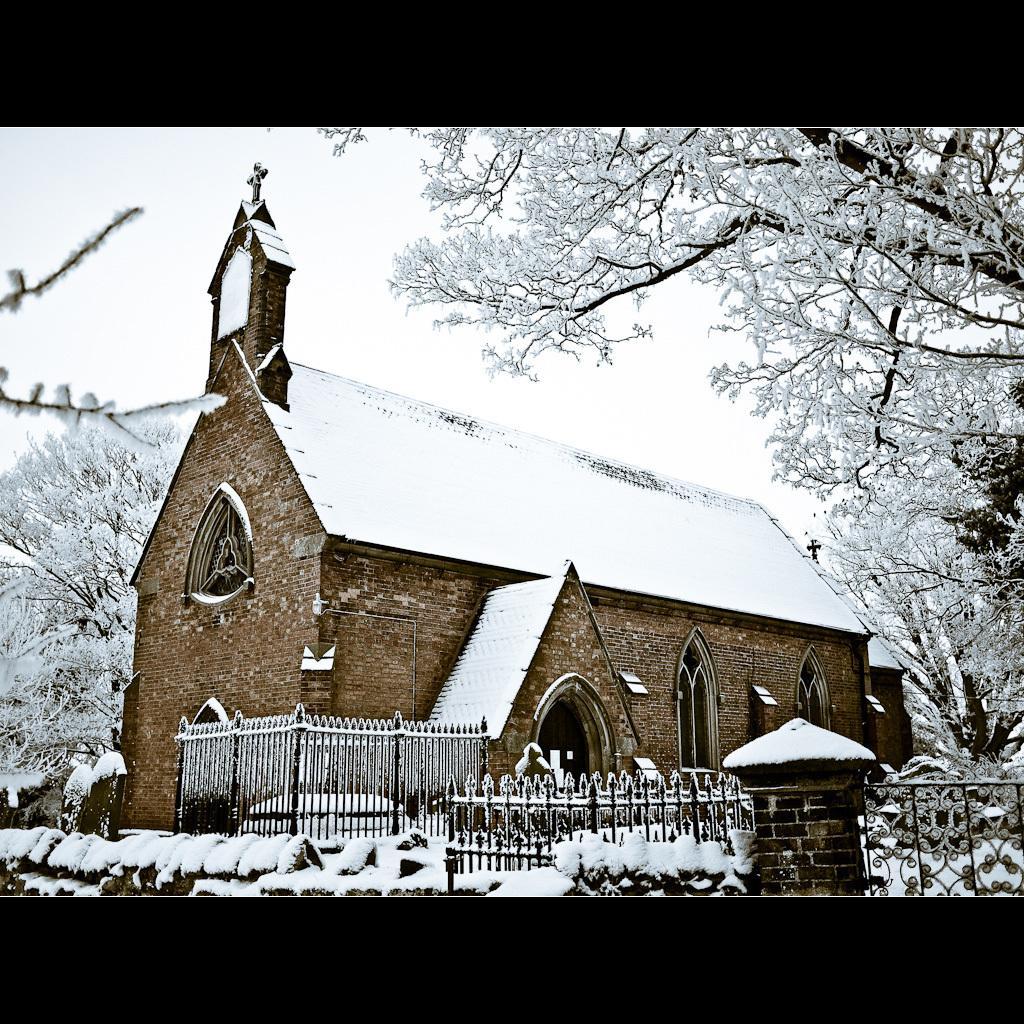Please provide a concise description of this image. In the foreground of the picture there are plants, railing, wall and stems of a tree and there is snow everywhere. In the center of the picture there are trees and a church. In the background it is sky, sky is cloudy. 